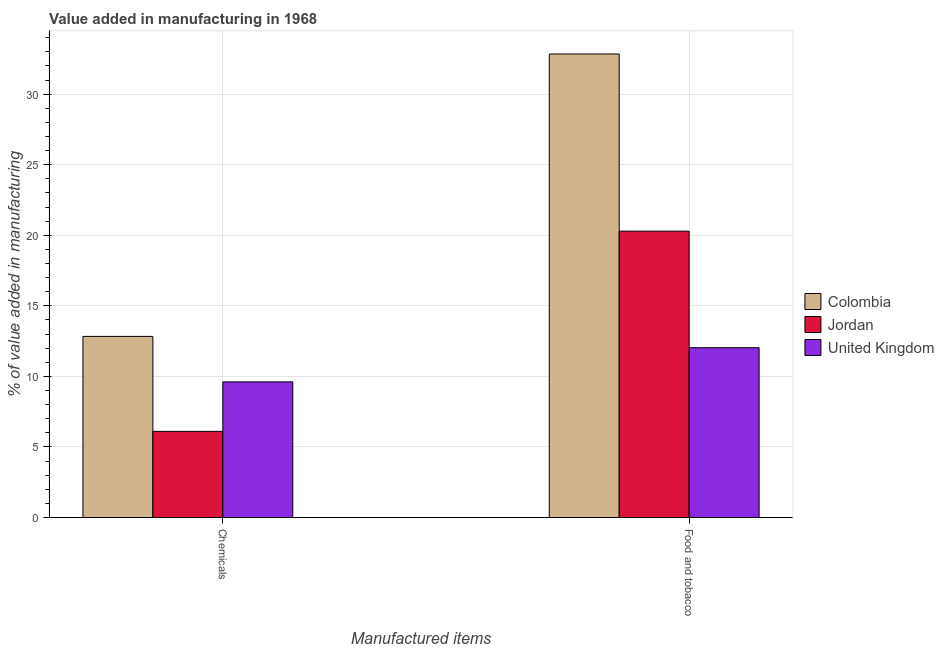How many different coloured bars are there?
Make the answer very short. 3. How many groups of bars are there?
Keep it short and to the point. 2. Are the number of bars on each tick of the X-axis equal?
Provide a succinct answer. Yes. How many bars are there on the 1st tick from the right?
Make the answer very short. 3. What is the label of the 2nd group of bars from the left?
Make the answer very short. Food and tobacco. What is the value added by manufacturing food and tobacco in Colombia?
Your response must be concise. 32.84. Across all countries, what is the maximum value added by manufacturing food and tobacco?
Give a very brief answer. 32.84. Across all countries, what is the minimum value added by manufacturing food and tobacco?
Give a very brief answer. 12.03. In which country was the value added by manufacturing food and tobacco maximum?
Your response must be concise. Colombia. What is the total value added by  manufacturing chemicals in the graph?
Your answer should be very brief. 28.56. What is the difference between the value added by  manufacturing chemicals in Colombia and that in Jordan?
Your response must be concise. 6.73. What is the difference between the value added by manufacturing food and tobacco in Jordan and the value added by  manufacturing chemicals in United Kingdom?
Make the answer very short. 10.68. What is the average value added by manufacturing food and tobacco per country?
Offer a very short reply. 21.72. What is the difference between the value added by  manufacturing chemicals and value added by manufacturing food and tobacco in Jordan?
Give a very brief answer. -14.19. What is the ratio of the value added by manufacturing food and tobacco in United Kingdom to that in Jordan?
Your answer should be very brief. 0.59. In how many countries, is the value added by manufacturing food and tobacco greater than the average value added by manufacturing food and tobacco taken over all countries?
Provide a succinct answer. 1. What does the 2nd bar from the left in Chemicals represents?
Your answer should be compact. Jordan. What does the 2nd bar from the right in Chemicals represents?
Ensure brevity in your answer.  Jordan. How many bars are there?
Make the answer very short. 6. Are all the bars in the graph horizontal?
Keep it short and to the point. No. How many countries are there in the graph?
Offer a terse response. 3. What is the difference between two consecutive major ticks on the Y-axis?
Ensure brevity in your answer.  5. What is the title of the graph?
Your answer should be compact. Value added in manufacturing in 1968. Does "Tajikistan" appear as one of the legend labels in the graph?
Keep it short and to the point. No. What is the label or title of the X-axis?
Provide a short and direct response. Manufactured items. What is the label or title of the Y-axis?
Offer a terse response. % of value added in manufacturing. What is the % of value added in manufacturing in Colombia in Chemicals?
Your response must be concise. 12.84. What is the % of value added in manufacturing in Jordan in Chemicals?
Provide a succinct answer. 6.11. What is the % of value added in manufacturing of United Kingdom in Chemicals?
Provide a short and direct response. 9.61. What is the % of value added in manufacturing of Colombia in Food and tobacco?
Ensure brevity in your answer.  32.84. What is the % of value added in manufacturing of Jordan in Food and tobacco?
Keep it short and to the point. 20.29. What is the % of value added in manufacturing of United Kingdom in Food and tobacco?
Provide a succinct answer. 12.03. Across all Manufactured items, what is the maximum % of value added in manufacturing in Colombia?
Offer a very short reply. 32.84. Across all Manufactured items, what is the maximum % of value added in manufacturing in Jordan?
Your answer should be compact. 20.29. Across all Manufactured items, what is the maximum % of value added in manufacturing of United Kingdom?
Offer a terse response. 12.03. Across all Manufactured items, what is the minimum % of value added in manufacturing of Colombia?
Your response must be concise. 12.84. Across all Manufactured items, what is the minimum % of value added in manufacturing of Jordan?
Offer a terse response. 6.11. Across all Manufactured items, what is the minimum % of value added in manufacturing in United Kingdom?
Make the answer very short. 9.61. What is the total % of value added in manufacturing of Colombia in the graph?
Keep it short and to the point. 45.68. What is the total % of value added in manufacturing of Jordan in the graph?
Your answer should be compact. 26.4. What is the total % of value added in manufacturing in United Kingdom in the graph?
Your answer should be compact. 21.65. What is the difference between the % of value added in manufacturing of Colombia in Chemicals and that in Food and tobacco?
Your answer should be compact. -20.01. What is the difference between the % of value added in manufacturing in Jordan in Chemicals and that in Food and tobacco?
Your response must be concise. -14.19. What is the difference between the % of value added in manufacturing of United Kingdom in Chemicals and that in Food and tobacco?
Provide a succinct answer. -2.42. What is the difference between the % of value added in manufacturing in Colombia in Chemicals and the % of value added in manufacturing in Jordan in Food and tobacco?
Your response must be concise. -7.46. What is the difference between the % of value added in manufacturing of Colombia in Chemicals and the % of value added in manufacturing of United Kingdom in Food and tobacco?
Provide a succinct answer. 0.8. What is the difference between the % of value added in manufacturing in Jordan in Chemicals and the % of value added in manufacturing in United Kingdom in Food and tobacco?
Ensure brevity in your answer.  -5.93. What is the average % of value added in manufacturing of Colombia per Manufactured items?
Offer a very short reply. 22.84. What is the average % of value added in manufacturing in Jordan per Manufactured items?
Give a very brief answer. 13.2. What is the average % of value added in manufacturing of United Kingdom per Manufactured items?
Your response must be concise. 10.82. What is the difference between the % of value added in manufacturing in Colombia and % of value added in manufacturing in Jordan in Chemicals?
Offer a very short reply. 6.73. What is the difference between the % of value added in manufacturing in Colombia and % of value added in manufacturing in United Kingdom in Chemicals?
Give a very brief answer. 3.22. What is the difference between the % of value added in manufacturing of Jordan and % of value added in manufacturing of United Kingdom in Chemicals?
Your answer should be very brief. -3.51. What is the difference between the % of value added in manufacturing in Colombia and % of value added in manufacturing in Jordan in Food and tobacco?
Your response must be concise. 12.55. What is the difference between the % of value added in manufacturing of Colombia and % of value added in manufacturing of United Kingdom in Food and tobacco?
Keep it short and to the point. 20.81. What is the difference between the % of value added in manufacturing in Jordan and % of value added in manufacturing in United Kingdom in Food and tobacco?
Offer a very short reply. 8.26. What is the ratio of the % of value added in manufacturing in Colombia in Chemicals to that in Food and tobacco?
Provide a short and direct response. 0.39. What is the ratio of the % of value added in manufacturing of Jordan in Chemicals to that in Food and tobacco?
Make the answer very short. 0.3. What is the ratio of the % of value added in manufacturing in United Kingdom in Chemicals to that in Food and tobacco?
Keep it short and to the point. 0.8. What is the difference between the highest and the second highest % of value added in manufacturing of Colombia?
Provide a succinct answer. 20.01. What is the difference between the highest and the second highest % of value added in manufacturing in Jordan?
Make the answer very short. 14.19. What is the difference between the highest and the second highest % of value added in manufacturing of United Kingdom?
Make the answer very short. 2.42. What is the difference between the highest and the lowest % of value added in manufacturing of Colombia?
Make the answer very short. 20.01. What is the difference between the highest and the lowest % of value added in manufacturing in Jordan?
Your answer should be very brief. 14.19. What is the difference between the highest and the lowest % of value added in manufacturing of United Kingdom?
Provide a short and direct response. 2.42. 